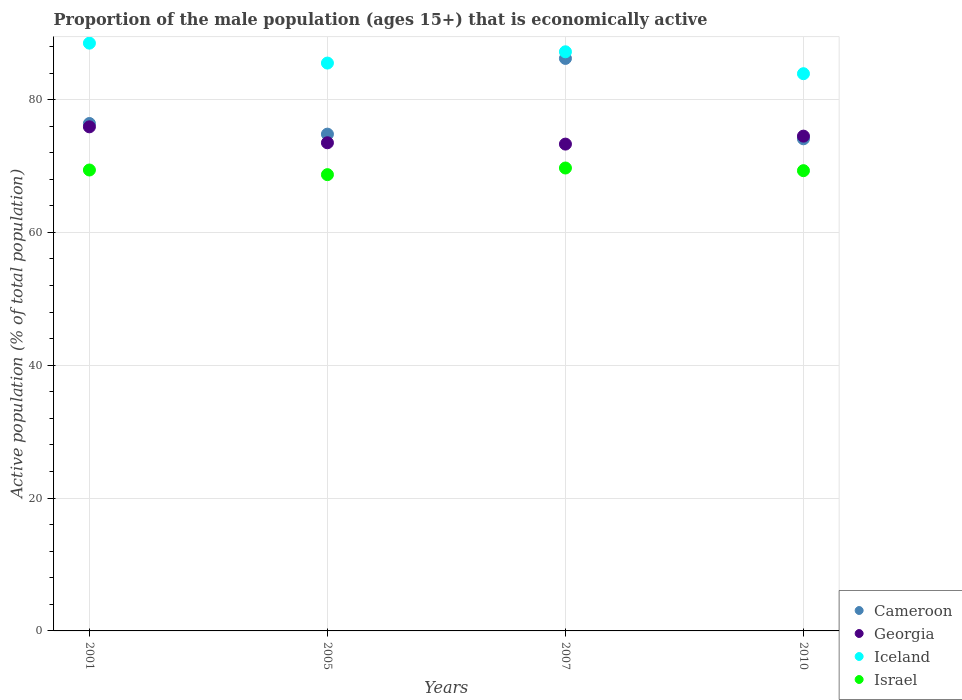What is the proportion of the male population that is economically active in Israel in 2007?
Offer a very short reply. 69.7. Across all years, what is the maximum proportion of the male population that is economically active in Israel?
Your answer should be compact. 69.7. Across all years, what is the minimum proportion of the male population that is economically active in Iceland?
Provide a short and direct response. 83.9. What is the total proportion of the male population that is economically active in Iceland in the graph?
Provide a succinct answer. 345.1. What is the difference between the proportion of the male population that is economically active in Cameroon in 2001 and that in 2010?
Keep it short and to the point. 2.3. What is the difference between the proportion of the male population that is economically active in Iceland in 2001 and the proportion of the male population that is economically active in Israel in 2005?
Offer a terse response. 19.8. What is the average proportion of the male population that is economically active in Cameroon per year?
Give a very brief answer. 77.87. In the year 2001, what is the difference between the proportion of the male population that is economically active in Iceland and proportion of the male population that is economically active in Cameroon?
Give a very brief answer. 12.1. In how many years, is the proportion of the male population that is economically active in Cameroon greater than 8 %?
Your answer should be very brief. 4. What is the ratio of the proportion of the male population that is economically active in Israel in 2001 to that in 2005?
Your response must be concise. 1.01. Is the difference between the proportion of the male population that is economically active in Iceland in 2001 and 2005 greater than the difference between the proportion of the male population that is economically active in Cameroon in 2001 and 2005?
Your answer should be compact. Yes. What is the difference between the highest and the second highest proportion of the male population that is economically active in Georgia?
Ensure brevity in your answer.  1.4. What is the difference between the highest and the lowest proportion of the male population that is economically active in Georgia?
Your response must be concise. 2.6. In how many years, is the proportion of the male population that is economically active in Georgia greater than the average proportion of the male population that is economically active in Georgia taken over all years?
Your answer should be very brief. 2. Is it the case that in every year, the sum of the proportion of the male population that is economically active in Georgia and proportion of the male population that is economically active in Cameroon  is greater than the sum of proportion of the male population that is economically active in Israel and proportion of the male population that is economically active in Iceland?
Provide a short and direct response. No. Is it the case that in every year, the sum of the proportion of the male population that is economically active in Iceland and proportion of the male population that is economically active in Cameroon  is greater than the proportion of the male population that is economically active in Israel?
Offer a terse response. Yes. Is the proportion of the male population that is economically active in Georgia strictly greater than the proportion of the male population that is economically active in Israel over the years?
Offer a very short reply. Yes. Is the proportion of the male population that is economically active in Iceland strictly less than the proportion of the male population that is economically active in Georgia over the years?
Your answer should be very brief. No. Does the graph contain any zero values?
Your answer should be compact. No. Where does the legend appear in the graph?
Offer a terse response. Bottom right. What is the title of the graph?
Provide a short and direct response. Proportion of the male population (ages 15+) that is economically active. What is the label or title of the Y-axis?
Offer a very short reply. Active population (% of total population). What is the Active population (% of total population) in Cameroon in 2001?
Your response must be concise. 76.4. What is the Active population (% of total population) of Georgia in 2001?
Keep it short and to the point. 75.9. What is the Active population (% of total population) in Iceland in 2001?
Ensure brevity in your answer.  88.5. What is the Active population (% of total population) of Israel in 2001?
Your response must be concise. 69.4. What is the Active population (% of total population) of Cameroon in 2005?
Offer a very short reply. 74.8. What is the Active population (% of total population) in Georgia in 2005?
Make the answer very short. 73.5. What is the Active population (% of total population) of Iceland in 2005?
Provide a short and direct response. 85.5. What is the Active population (% of total population) of Israel in 2005?
Keep it short and to the point. 68.7. What is the Active population (% of total population) of Cameroon in 2007?
Ensure brevity in your answer.  86.2. What is the Active population (% of total population) in Georgia in 2007?
Provide a short and direct response. 73.3. What is the Active population (% of total population) in Iceland in 2007?
Offer a terse response. 87.2. What is the Active population (% of total population) of Israel in 2007?
Your answer should be very brief. 69.7. What is the Active population (% of total population) in Cameroon in 2010?
Your response must be concise. 74.1. What is the Active population (% of total population) of Georgia in 2010?
Make the answer very short. 74.5. What is the Active population (% of total population) of Iceland in 2010?
Ensure brevity in your answer.  83.9. What is the Active population (% of total population) in Israel in 2010?
Offer a terse response. 69.3. Across all years, what is the maximum Active population (% of total population) of Cameroon?
Provide a succinct answer. 86.2. Across all years, what is the maximum Active population (% of total population) of Georgia?
Provide a succinct answer. 75.9. Across all years, what is the maximum Active population (% of total population) in Iceland?
Give a very brief answer. 88.5. Across all years, what is the maximum Active population (% of total population) of Israel?
Your answer should be compact. 69.7. Across all years, what is the minimum Active population (% of total population) in Cameroon?
Your answer should be compact. 74.1. Across all years, what is the minimum Active population (% of total population) of Georgia?
Ensure brevity in your answer.  73.3. Across all years, what is the minimum Active population (% of total population) in Iceland?
Offer a very short reply. 83.9. Across all years, what is the minimum Active population (% of total population) of Israel?
Give a very brief answer. 68.7. What is the total Active population (% of total population) in Cameroon in the graph?
Provide a succinct answer. 311.5. What is the total Active population (% of total population) of Georgia in the graph?
Your answer should be very brief. 297.2. What is the total Active population (% of total population) in Iceland in the graph?
Ensure brevity in your answer.  345.1. What is the total Active population (% of total population) in Israel in the graph?
Offer a terse response. 277.1. What is the difference between the Active population (% of total population) in Cameroon in 2001 and that in 2005?
Offer a terse response. 1.6. What is the difference between the Active population (% of total population) in Iceland in 2001 and that in 2005?
Your answer should be very brief. 3. What is the difference between the Active population (% of total population) of Georgia in 2001 and that in 2007?
Your response must be concise. 2.6. What is the difference between the Active population (% of total population) of Iceland in 2001 and that in 2007?
Keep it short and to the point. 1.3. What is the difference between the Active population (% of total population) of Georgia in 2001 and that in 2010?
Ensure brevity in your answer.  1.4. What is the difference between the Active population (% of total population) of Cameroon in 2005 and that in 2007?
Your answer should be very brief. -11.4. What is the difference between the Active population (% of total population) of Iceland in 2005 and that in 2007?
Your answer should be compact. -1.7. What is the difference between the Active population (% of total population) in Israel in 2005 and that in 2007?
Keep it short and to the point. -1. What is the difference between the Active population (% of total population) of Israel in 2005 and that in 2010?
Make the answer very short. -0.6. What is the difference between the Active population (% of total population) in Iceland in 2007 and that in 2010?
Ensure brevity in your answer.  3.3. What is the difference between the Active population (% of total population) in Cameroon in 2001 and the Active population (% of total population) in Georgia in 2005?
Your answer should be compact. 2.9. What is the difference between the Active population (% of total population) in Iceland in 2001 and the Active population (% of total population) in Israel in 2005?
Provide a succinct answer. 19.8. What is the difference between the Active population (% of total population) in Cameroon in 2001 and the Active population (% of total population) in Iceland in 2007?
Keep it short and to the point. -10.8. What is the difference between the Active population (% of total population) of Georgia in 2001 and the Active population (% of total population) of Iceland in 2007?
Provide a short and direct response. -11.3. What is the difference between the Active population (% of total population) of Iceland in 2001 and the Active population (% of total population) of Israel in 2007?
Ensure brevity in your answer.  18.8. What is the difference between the Active population (% of total population) in Iceland in 2001 and the Active population (% of total population) in Israel in 2010?
Your answer should be compact. 19.2. What is the difference between the Active population (% of total population) in Georgia in 2005 and the Active population (% of total population) in Iceland in 2007?
Provide a short and direct response. -13.7. What is the difference between the Active population (% of total population) of Georgia in 2005 and the Active population (% of total population) of Israel in 2007?
Make the answer very short. 3.8. What is the difference between the Active population (% of total population) in Georgia in 2005 and the Active population (% of total population) in Iceland in 2010?
Provide a succinct answer. -10.4. What is the difference between the Active population (% of total population) in Iceland in 2005 and the Active population (% of total population) in Israel in 2010?
Make the answer very short. 16.2. What is the difference between the Active population (% of total population) in Cameroon in 2007 and the Active population (% of total population) in Georgia in 2010?
Ensure brevity in your answer.  11.7. What is the difference between the Active population (% of total population) of Cameroon in 2007 and the Active population (% of total population) of Israel in 2010?
Keep it short and to the point. 16.9. What is the difference between the Active population (% of total population) of Iceland in 2007 and the Active population (% of total population) of Israel in 2010?
Keep it short and to the point. 17.9. What is the average Active population (% of total population) of Cameroon per year?
Your answer should be compact. 77.88. What is the average Active population (% of total population) in Georgia per year?
Offer a terse response. 74.3. What is the average Active population (% of total population) of Iceland per year?
Give a very brief answer. 86.28. What is the average Active population (% of total population) of Israel per year?
Give a very brief answer. 69.28. In the year 2001, what is the difference between the Active population (% of total population) in Cameroon and Active population (% of total population) in Iceland?
Your response must be concise. -12.1. In the year 2001, what is the difference between the Active population (% of total population) in Cameroon and Active population (% of total population) in Israel?
Offer a very short reply. 7. In the year 2001, what is the difference between the Active population (% of total population) of Georgia and Active population (% of total population) of Iceland?
Offer a very short reply. -12.6. In the year 2001, what is the difference between the Active population (% of total population) in Iceland and Active population (% of total population) in Israel?
Offer a very short reply. 19.1. In the year 2005, what is the difference between the Active population (% of total population) of Cameroon and Active population (% of total population) of Georgia?
Give a very brief answer. 1.3. In the year 2005, what is the difference between the Active population (% of total population) of Cameroon and Active population (% of total population) of Israel?
Provide a short and direct response. 6.1. In the year 2005, what is the difference between the Active population (% of total population) in Georgia and Active population (% of total population) in Iceland?
Keep it short and to the point. -12. In the year 2005, what is the difference between the Active population (% of total population) in Iceland and Active population (% of total population) in Israel?
Your response must be concise. 16.8. In the year 2007, what is the difference between the Active population (% of total population) of Cameroon and Active population (% of total population) of Iceland?
Provide a succinct answer. -1. In the year 2010, what is the difference between the Active population (% of total population) in Cameroon and Active population (% of total population) in Iceland?
Offer a terse response. -9.8. In the year 2010, what is the difference between the Active population (% of total population) of Georgia and Active population (% of total population) of Iceland?
Offer a very short reply. -9.4. In the year 2010, what is the difference between the Active population (% of total population) in Georgia and Active population (% of total population) in Israel?
Offer a very short reply. 5.2. What is the ratio of the Active population (% of total population) in Cameroon in 2001 to that in 2005?
Ensure brevity in your answer.  1.02. What is the ratio of the Active population (% of total population) of Georgia in 2001 to that in 2005?
Provide a short and direct response. 1.03. What is the ratio of the Active population (% of total population) of Iceland in 2001 to that in 2005?
Keep it short and to the point. 1.04. What is the ratio of the Active population (% of total population) in Israel in 2001 to that in 2005?
Your answer should be compact. 1.01. What is the ratio of the Active population (% of total population) in Cameroon in 2001 to that in 2007?
Provide a succinct answer. 0.89. What is the ratio of the Active population (% of total population) of Georgia in 2001 to that in 2007?
Offer a very short reply. 1.04. What is the ratio of the Active population (% of total population) in Iceland in 2001 to that in 2007?
Keep it short and to the point. 1.01. What is the ratio of the Active population (% of total population) of Israel in 2001 to that in 2007?
Give a very brief answer. 1. What is the ratio of the Active population (% of total population) in Cameroon in 2001 to that in 2010?
Give a very brief answer. 1.03. What is the ratio of the Active population (% of total population) in Georgia in 2001 to that in 2010?
Ensure brevity in your answer.  1.02. What is the ratio of the Active population (% of total population) in Iceland in 2001 to that in 2010?
Provide a succinct answer. 1.05. What is the ratio of the Active population (% of total population) in Cameroon in 2005 to that in 2007?
Your answer should be compact. 0.87. What is the ratio of the Active population (% of total population) in Iceland in 2005 to that in 2007?
Make the answer very short. 0.98. What is the ratio of the Active population (% of total population) in Israel in 2005 to that in 2007?
Your answer should be compact. 0.99. What is the ratio of the Active population (% of total population) of Cameroon in 2005 to that in 2010?
Provide a short and direct response. 1.01. What is the ratio of the Active population (% of total population) in Georgia in 2005 to that in 2010?
Offer a terse response. 0.99. What is the ratio of the Active population (% of total population) in Iceland in 2005 to that in 2010?
Your answer should be very brief. 1.02. What is the ratio of the Active population (% of total population) in Cameroon in 2007 to that in 2010?
Offer a very short reply. 1.16. What is the ratio of the Active population (% of total population) in Georgia in 2007 to that in 2010?
Make the answer very short. 0.98. What is the ratio of the Active population (% of total population) in Iceland in 2007 to that in 2010?
Provide a short and direct response. 1.04. What is the ratio of the Active population (% of total population) in Israel in 2007 to that in 2010?
Your response must be concise. 1.01. What is the difference between the highest and the second highest Active population (% of total population) in Cameroon?
Your response must be concise. 9.8. What is the difference between the highest and the second highest Active population (% of total population) of Georgia?
Offer a very short reply. 1.4. What is the difference between the highest and the second highest Active population (% of total population) of Israel?
Your answer should be compact. 0.3. What is the difference between the highest and the lowest Active population (% of total population) in Georgia?
Provide a short and direct response. 2.6. What is the difference between the highest and the lowest Active population (% of total population) in Israel?
Provide a short and direct response. 1. 